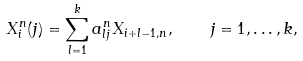Convert formula to latex. <formula><loc_0><loc_0><loc_500><loc_500>X _ { i } ^ { n } ( j ) = \sum _ { l = 1 } ^ { k } a _ { l j } ^ { n } X _ { i + l - 1 , n } , \quad j = 1 , \dots , k ,</formula> 